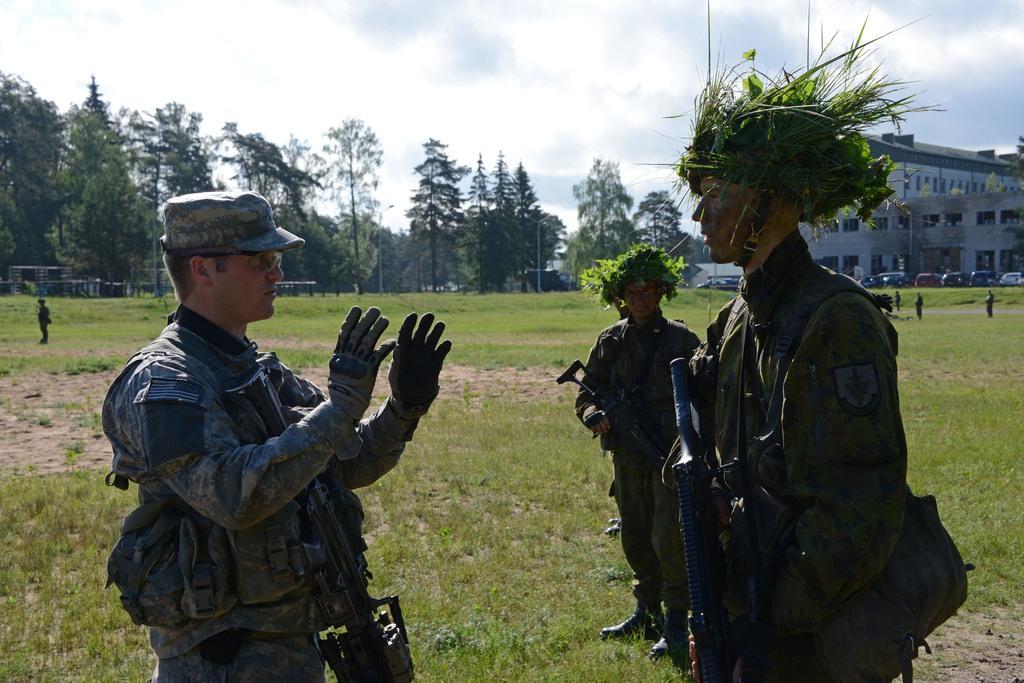How would you summarize this image in a sentence or two? This is an outside view. Here I can see wearing uniform and standing by holding mics in their hands. On the left side the person who is standing is telling something to the remaining people. On the top of the image I can see the sky. In the background there are few trees and a building. In front of this building there are few cars. 